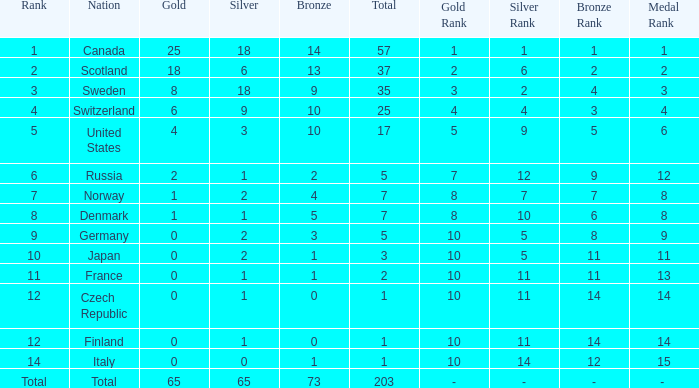What is the number of bronze medals when the total is greater than 1, more than 2 silver medals are won, and the rank is 2? 13.0. Parse the table in full. {'header': ['Rank', 'Nation', 'Gold', 'Silver', 'Bronze', 'Total', 'Gold Rank', 'Silver Rank', 'Bronze Rank', 'Medal Rank'], 'rows': [['1', 'Canada', '25', '18', '14', '57', '1', '1', '1', '1'], ['2', 'Scotland', '18', '6', '13', '37', '2', '6', '2', '2'], ['3', 'Sweden', '8', '18', '9', '35', '3', '2', '4', '3'], ['4', 'Switzerland', '6', '9', '10', '25', '4', '4', '3', '4'], ['5', 'United States', '4', '3', '10', '17', '5', '9', '5', '6'], ['6', 'Russia', '2', '1', '2', '5', '7', '12', '9', '12'], ['7', 'Norway', '1', '2', '4', '7', '8', '7', '7', '8'], ['8', 'Denmark', '1', '1', '5', '7', '8', '10', '6', '8'], ['9', 'Germany', '0', '2', '3', '5', '10', '5', '8', '9'], ['10', 'Japan', '0', '2', '1', '3', '10', '5', '11', '11'], ['11', 'France', '0', '1', '1', '2', '10', '11', '11', '13'], ['12', 'Czech Republic', '0', '1', '0', '1', '10', '11', '14', '14'], ['12', 'Finland', '0', '1', '0', '1', '10', '11', '14', '14'], ['14', 'Italy', '0', '0', '1', '1', '10', '14', '12', '15'], ['Total', 'Total', '65', '65', '73', '203', '-', '-', '-', '- ']]} 